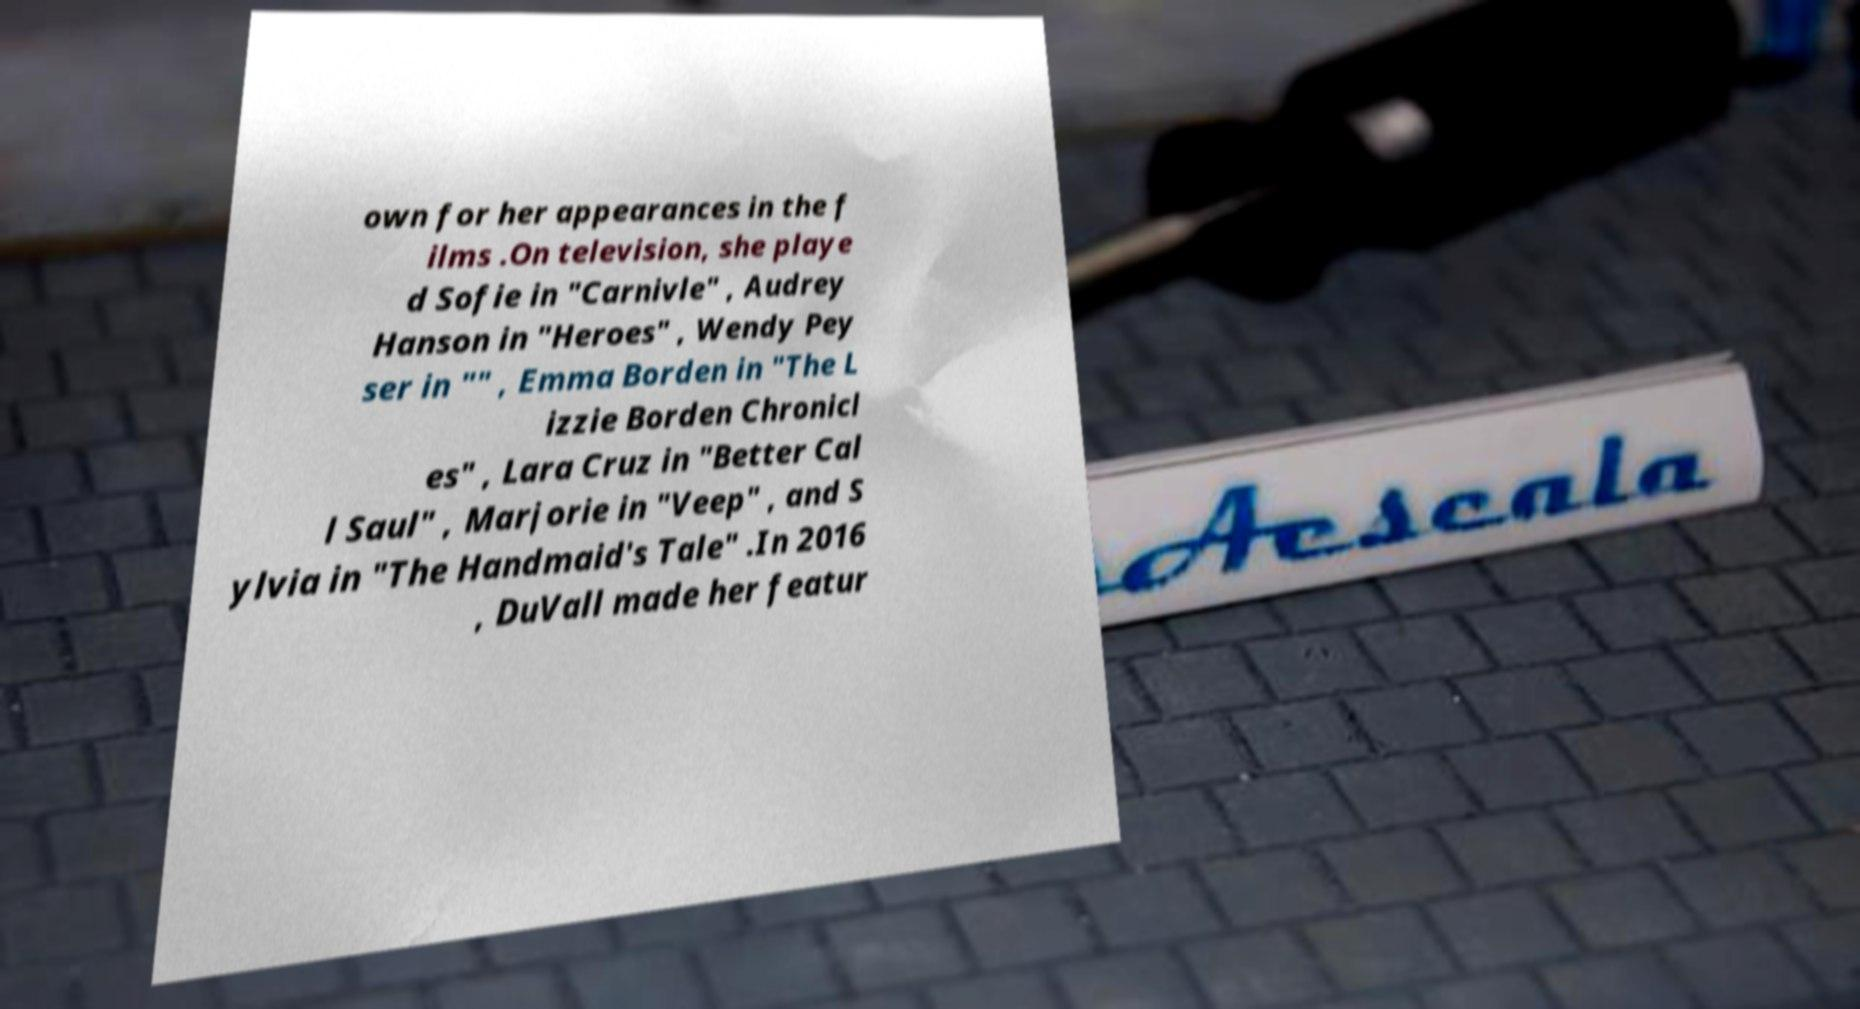What messages or text are displayed in this image? I need them in a readable, typed format. own for her appearances in the f ilms .On television, she playe d Sofie in "Carnivle" , Audrey Hanson in "Heroes" , Wendy Pey ser in "" , Emma Borden in "The L izzie Borden Chronicl es" , Lara Cruz in "Better Cal l Saul" , Marjorie in "Veep" , and S ylvia in "The Handmaid's Tale" .In 2016 , DuVall made her featur 